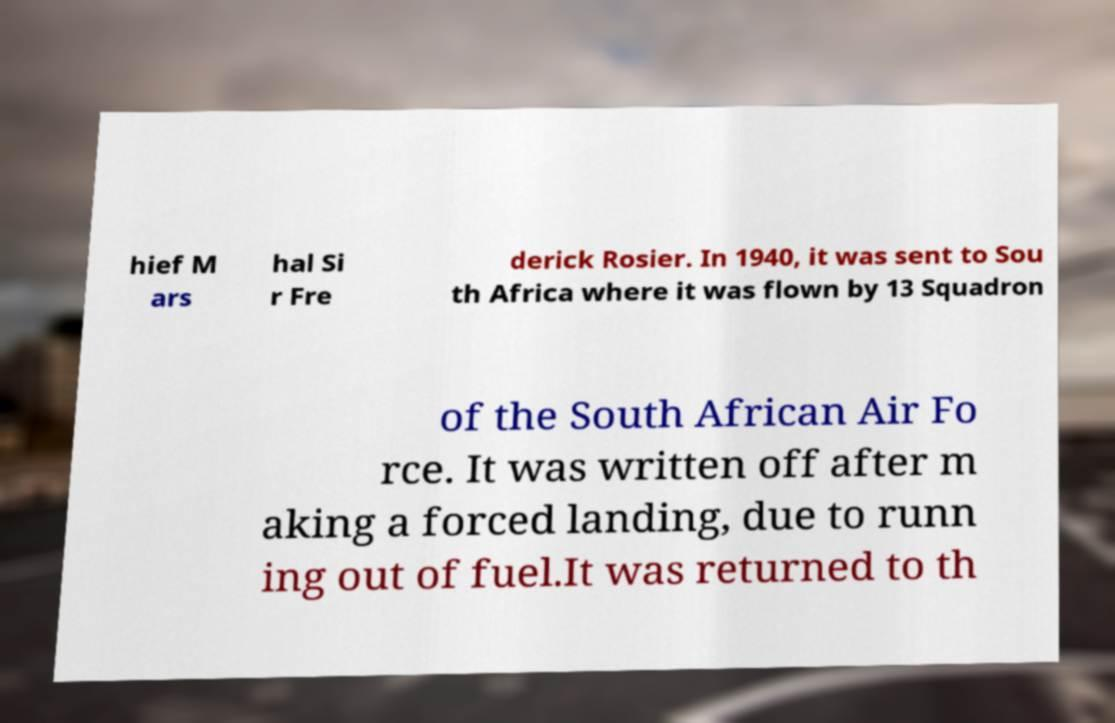Please identify and transcribe the text found in this image. hief M ars hal Si r Fre derick Rosier. In 1940, it was sent to Sou th Africa where it was flown by 13 Squadron of the South African Air Fo rce. It was written off after m aking a forced landing, due to runn ing out of fuel.It was returned to th 